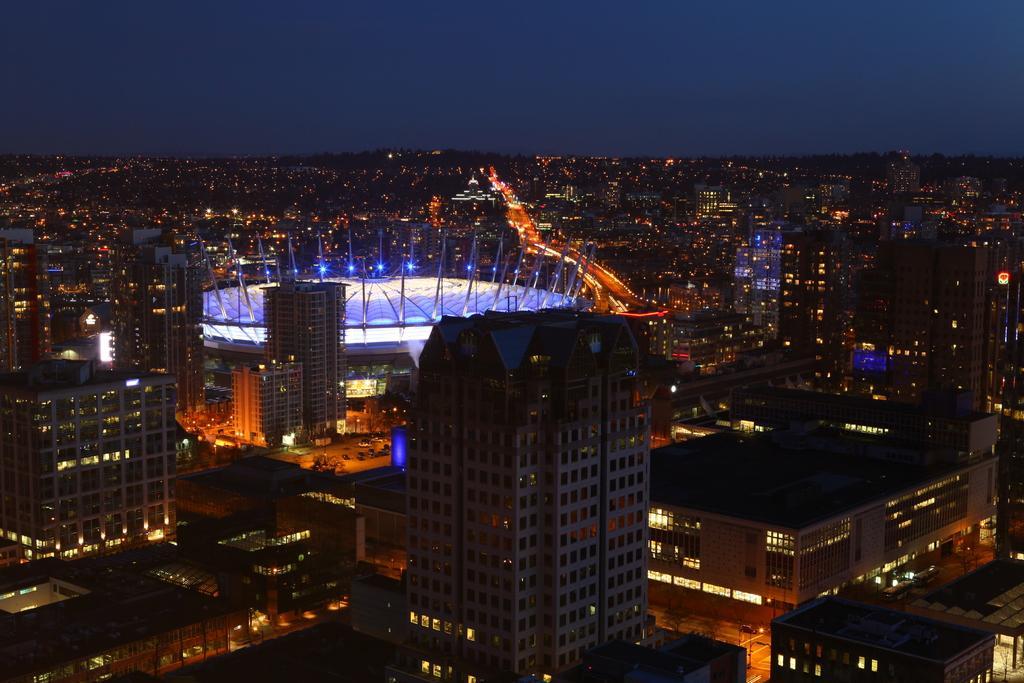Could you give a brief overview of what you see in this image? In this picture we can see buildings with windows, lights, roads and in the background we can see the sky. 